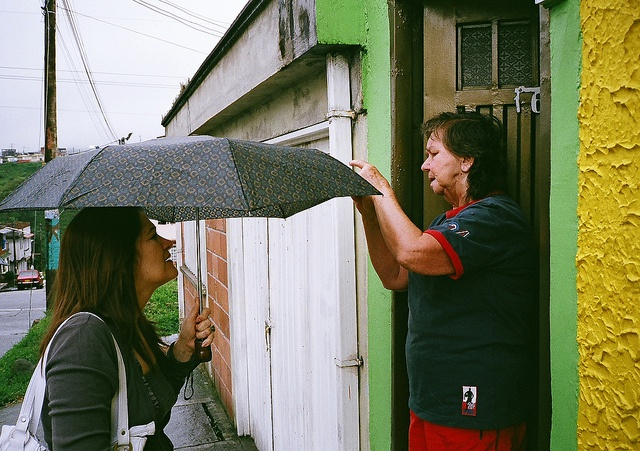Describe the objects in this image and their specific colors. I can see people in lavender, black, maroon, and lightpink tones, people in lavender, black, olive, maroon, and gray tones, umbrella in lavender, gray, black, and darkgray tones, handbag in lavender, darkgray, and black tones, and car in lavender, black, darkgray, maroon, and gray tones in this image. 